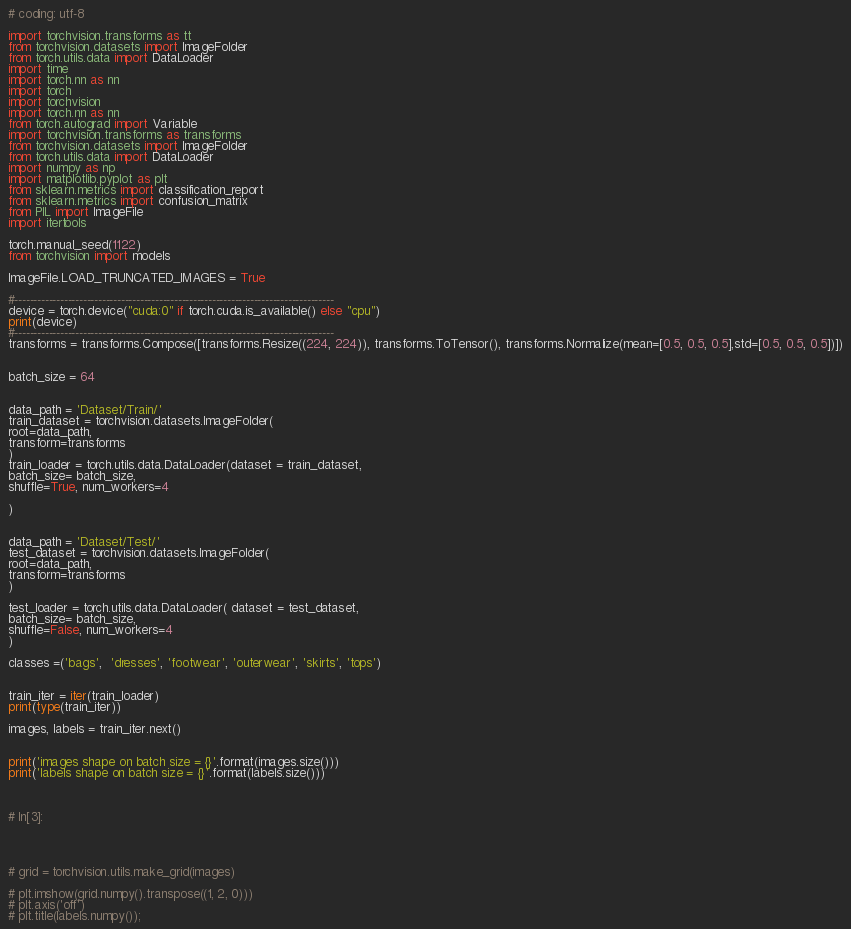<code> <loc_0><loc_0><loc_500><loc_500><_Python_># coding: utf-8

import torchvision.transforms as tt
from torchvision.datasets import ImageFolder
from torch.utils.data import DataLoader
import time
import torch.nn as nn
import torch
import torchvision
import torch.nn as nn
from torch.autograd import Variable
import torchvision.transforms as transforms
from torchvision.datasets import ImageFolder
from torch.utils.data import DataLoader
import numpy as np
import matplotlib.pyplot as plt
from sklearn.metrics import classification_report
from sklearn.metrics import confusion_matrix
from PIL import ImageFile
import itertools

torch.manual_seed(1122)
from torchvision import models

ImageFile.LOAD_TRUNCATED_IMAGES = True

#------------------------------------------------------------------------------------
device = torch.device("cuda:0" if torch.cuda.is_available() else "cpu")
print(device)
#------------------------------------------------------------------------------------
transforms = transforms.Compose([transforms.Resize((224, 224)), transforms.ToTensor(), transforms.Normalize(mean=[0.5, 0.5, 0.5],std=[0.5, 0.5, 0.5])])


batch_size = 64


data_path = 'Dataset/Train/'
train_dataset = torchvision.datasets.ImageFolder(
root=data_path,
transform=transforms
)
train_loader = torch.utils.data.DataLoader(dataset = train_dataset,
batch_size= batch_size,
shuffle=True, num_workers=4

)


data_path = 'Dataset/Test/'
test_dataset = torchvision.datasets.ImageFolder(
root=data_path,
transform=transforms
)

test_loader = torch.utils.data.DataLoader( dataset = test_dataset,
batch_size= batch_size,
shuffle=False, num_workers=4
)

classes =('bags',  'dresses', 'footwear', 'outerwear', 'skirts', 'tops')


train_iter = iter(train_loader)
print(type(train_iter))

images, labels = train_iter.next()


print('images shape on batch size = {}'.format(images.size()))
print('labels shape on batch size = {}'.format(labels.size()))



# In[3]:




# grid = torchvision.utils.make_grid(images)

# plt.imshow(grid.numpy().transpose((1, 2, 0)))
# plt.axis('off')
# plt.title(labels.numpy());</code> 